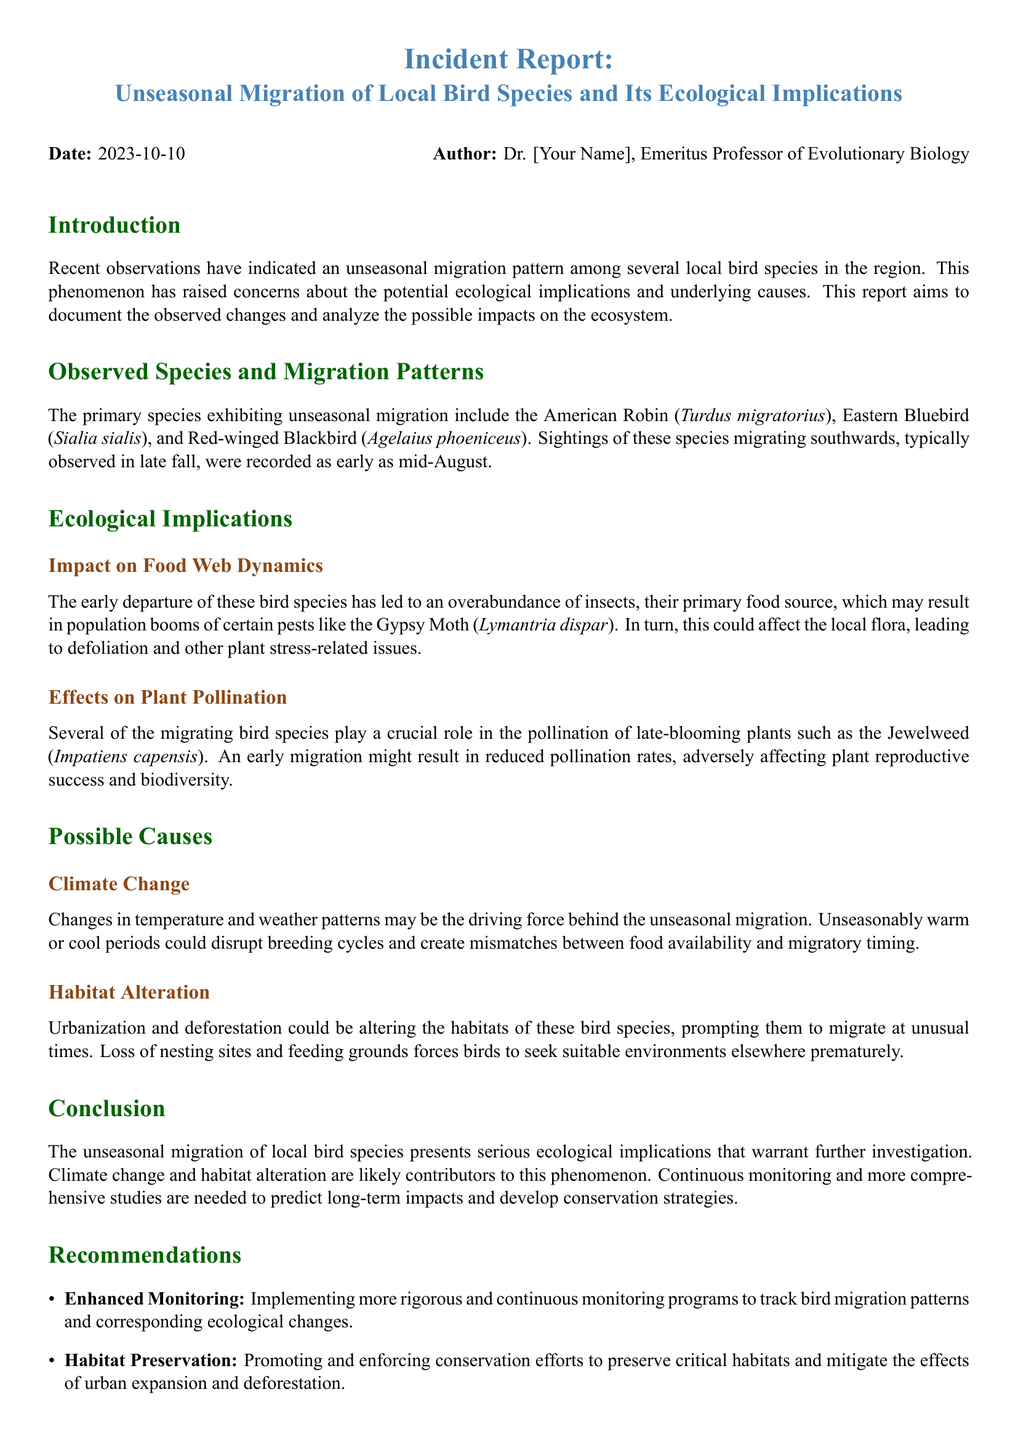what is the date of the report? The date of the report is specified at the beginning of the document.
Answer: 2023-10-10 who is the author of the report? The author's name is listed as the person who compiled the report.
Answer: Dr. [Your Name] which bird species are mentioned in the report? The report lists specific bird species that are noted for their unseasonal migration patterns.
Answer: American Robin, Eastern Bluebird, Red-winged Blackbird what is a potential ecological impact of the early departure of the migrating birds? The document discusses effects on food web dynamics as a result of the migration patterns.
Answer: Overabundance of insects what primary cause of unseasonal migration is highlighted in the report? The document identifies overarching factors contributing to the observed migration patterns.
Answer: Climate Change which plant is specifically mentioned as affected by decreased pollination? The report refers to particular plants that rely on the migrating birds for pollination.
Answer: Jewelweed how many recommendations are provided in the report? The report outlines specific recommendations for addressing the issue discussed.
Answer: Three what type of monitoring is suggested to be enhanced? The recommendations section indicates specific areas for improved oversight.
Answer: Bird migration patterns what is one aspect of habitat alteration mentioned in the document? The section on possible causes explains particular issues regarding habitats of bird species.
Answer: Urbanization and deforestation 